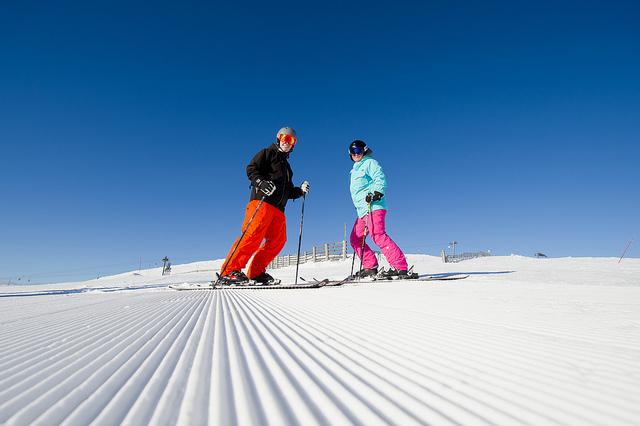Is the snowboarder squatting?
Keep it brief. No. What color are the pants of the skiers?
Be succinct. Red. What color is the sky?
Short answer required. Blue. What are they doing?
Write a very short answer. Skiing. What are in the snow?
Quick response, please. Skiers. 